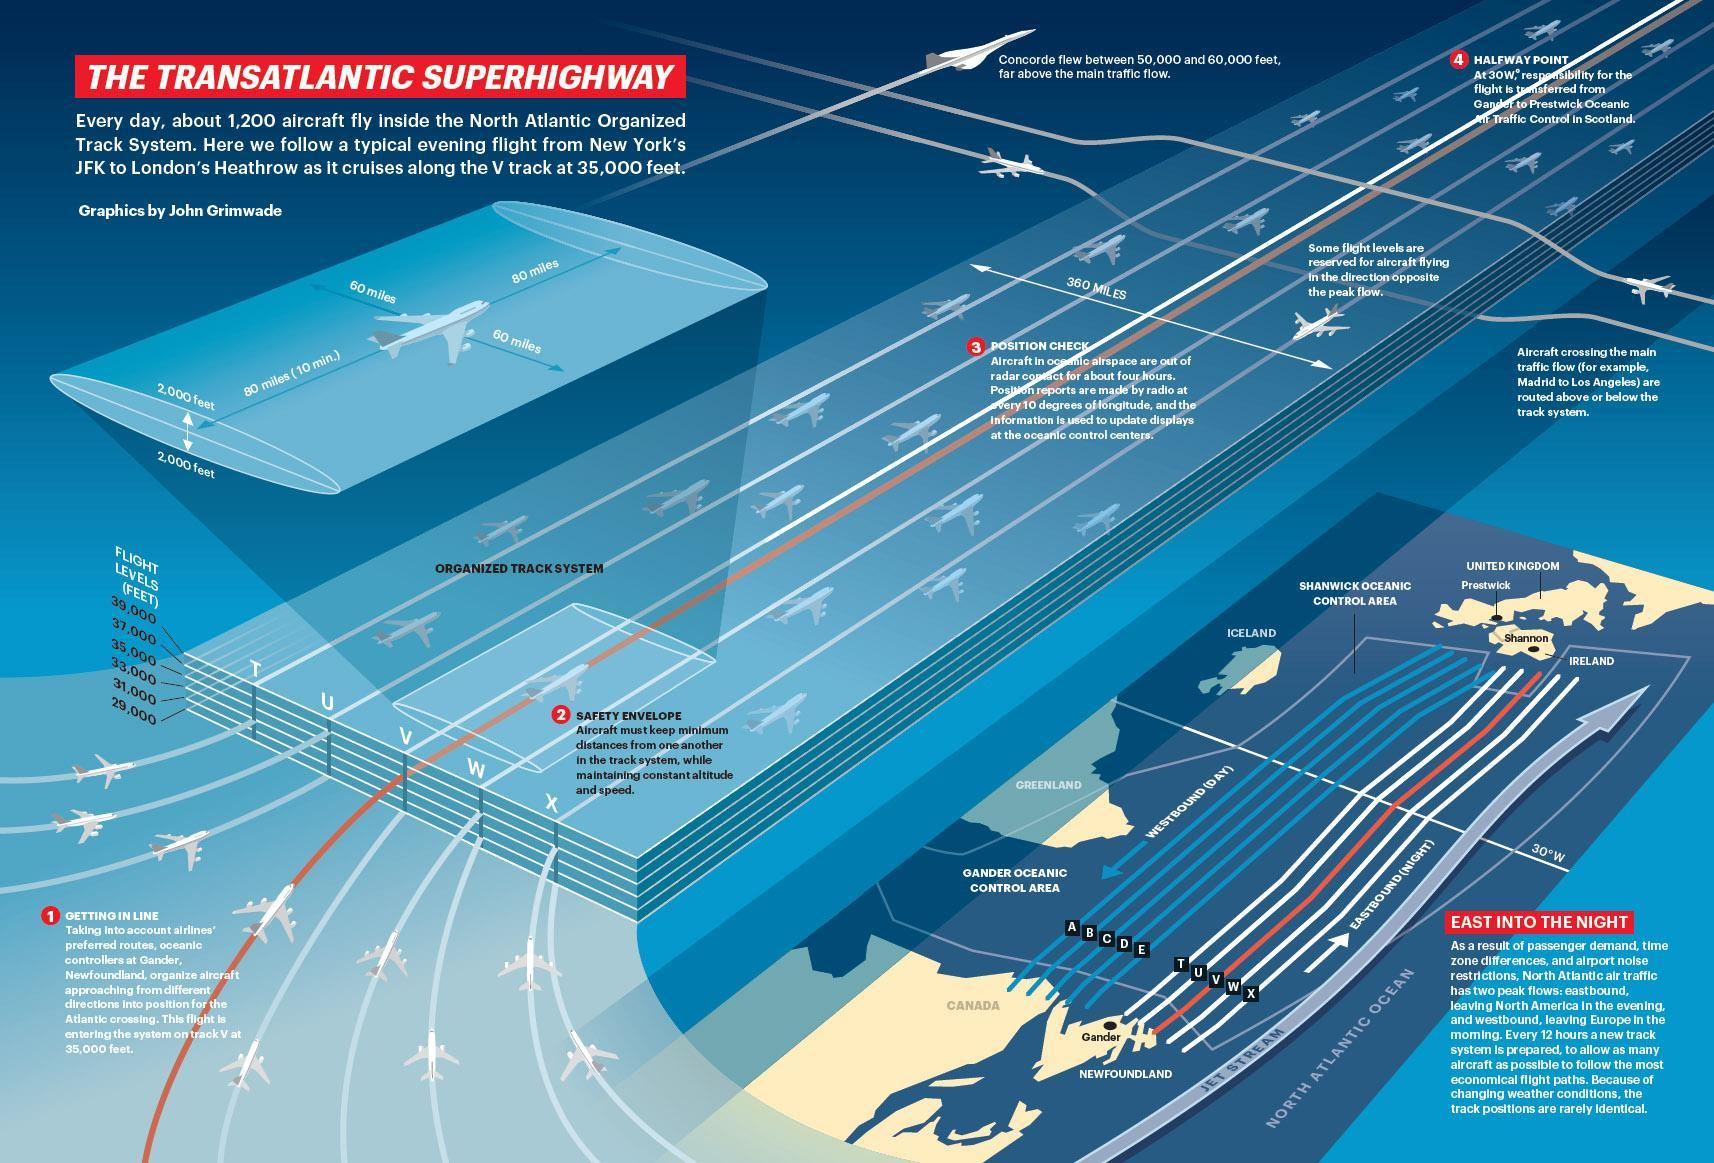What is the breadth of the Organized Track System as given in the info graphic?
Answer the question with a short phrase. 360 MILES 